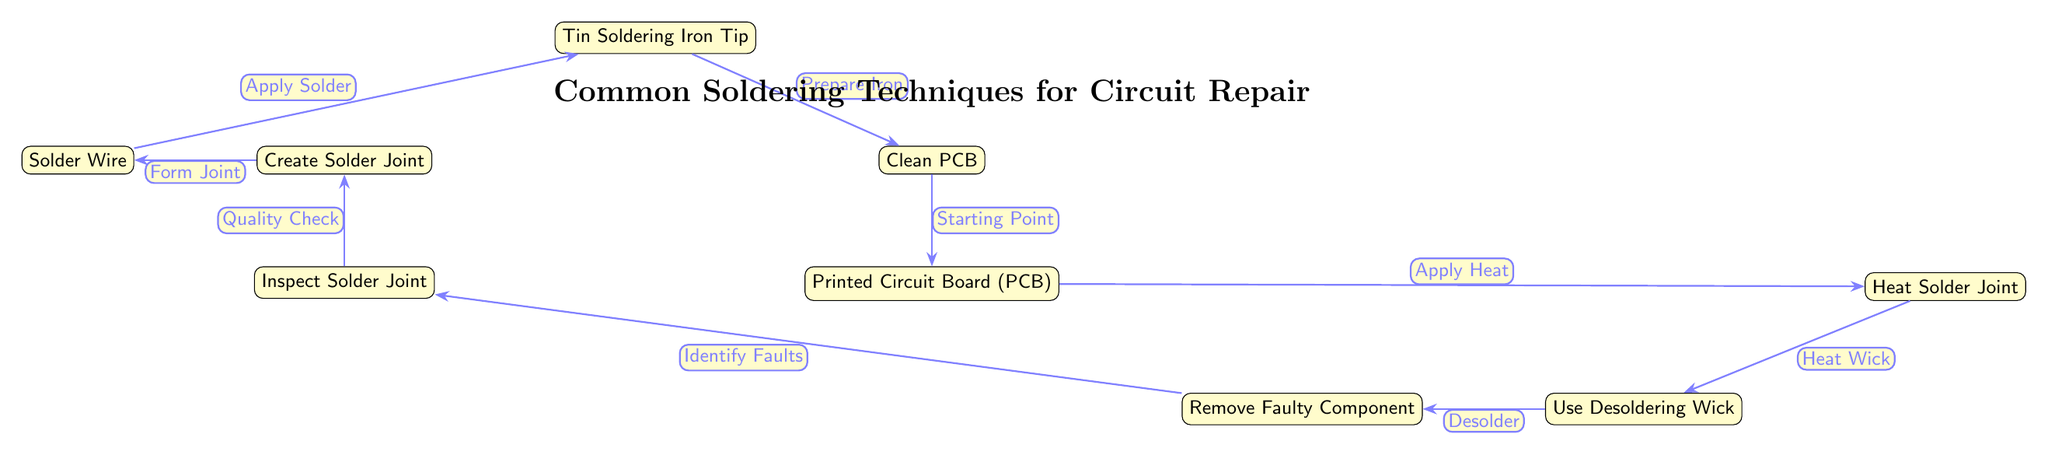What is the starting point in the diagram? The starting point in the diagram is denoted by the edge label "Starting Point" that connects "Clean PCB" to "Printed Circuit Board".
Answer: Clean PCB How many nodes are there in the diagram? By counting all the individual labeled boxes from the diagram, we find a total of 8 nodes.
Answer: 8 What does "Heat Joint" connect to? The "Heat Joint" node connects to the "PCB" node and the "Desoldering Wick" node.
Answer: PCB, Desoldering Wick Which step follows "Inspect Solder Joint"? According to the flow of the diagram, the step that follows "Inspect Solder Joint" is "Remove Faulty Component".
Answer: Remove Faulty Component Which operation is placed before "Create Solder Joint"? The operation that comes before "Create Solder Joint" is "Apply Solder". This is indicated in the diagram through the edge label.
Answer: Apply Solder What is the purpose of "Desoldering Wick" in the process? The purpose of "Desoldering Wick," indicated as "Desolder," is to assist in the removal of the faulty component by heating the solder joint.
Answer: Remove faulty component How many edges are used to connect the nodes? Counting the lines connecting the nodes, there are a total of 8 edges in the diagram.
Answer: 8 Which nodes are involved in checking the quality of the solder joint? The nodes involved in checking the quality of the solder joint are "Inspect Solder Joint" and "Create Solder Joint". The connection indicates a quality check is performed after forming the joint.
Answer: Inspect Solder Joint, Create Solder Joint What is the last step before "Remove Faulty Component"? The last step before reaching "Remove Faulty Component" is "Inspect Solder Joint", which indicates that faults should be identified before proceeding.
Answer: Inspect Solder Joint 